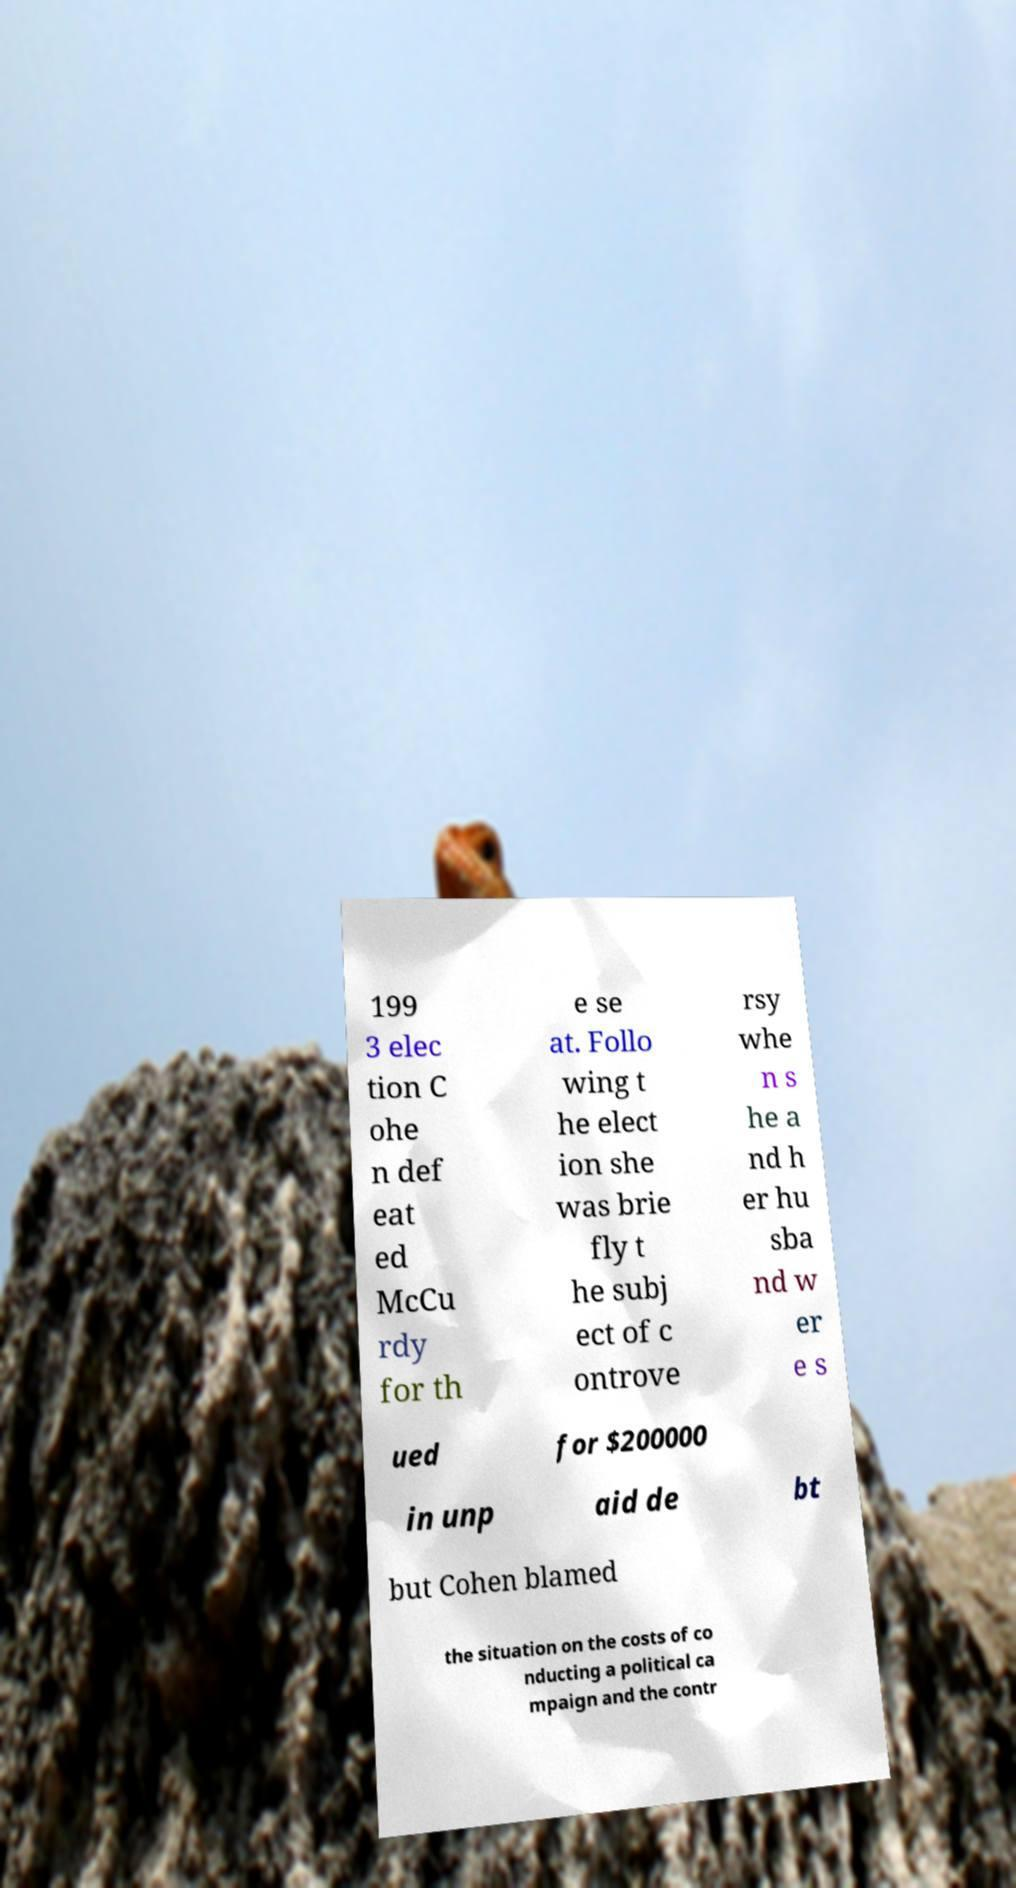Please identify and transcribe the text found in this image. 199 3 elec tion C ohe n def eat ed McCu rdy for th e se at. Follo wing t he elect ion she was brie fly t he subj ect of c ontrove rsy whe n s he a nd h er hu sba nd w er e s ued for $200000 in unp aid de bt but Cohen blamed the situation on the costs of co nducting a political ca mpaign and the contr 